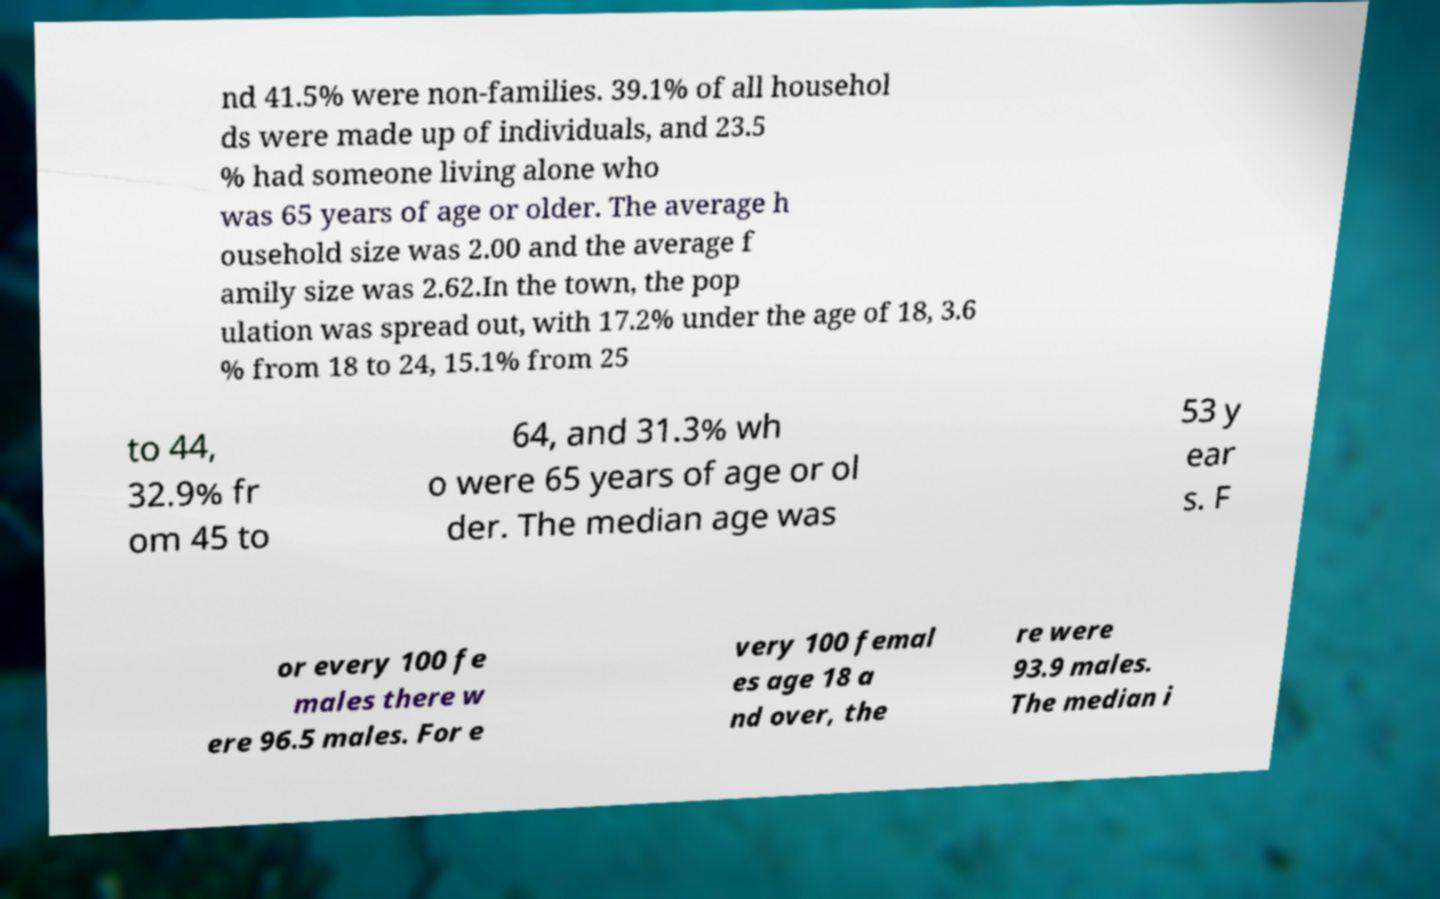I need the written content from this picture converted into text. Can you do that? nd 41.5% were non-families. 39.1% of all househol ds were made up of individuals, and 23.5 % had someone living alone who was 65 years of age or older. The average h ousehold size was 2.00 and the average f amily size was 2.62.In the town, the pop ulation was spread out, with 17.2% under the age of 18, 3.6 % from 18 to 24, 15.1% from 25 to 44, 32.9% fr om 45 to 64, and 31.3% wh o were 65 years of age or ol der. The median age was 53 y ear s. F or every 100 fe males there w ere 96.5 males. For e very 100 femal es age 18 a nd over, the re were 93.9 males. The median i 